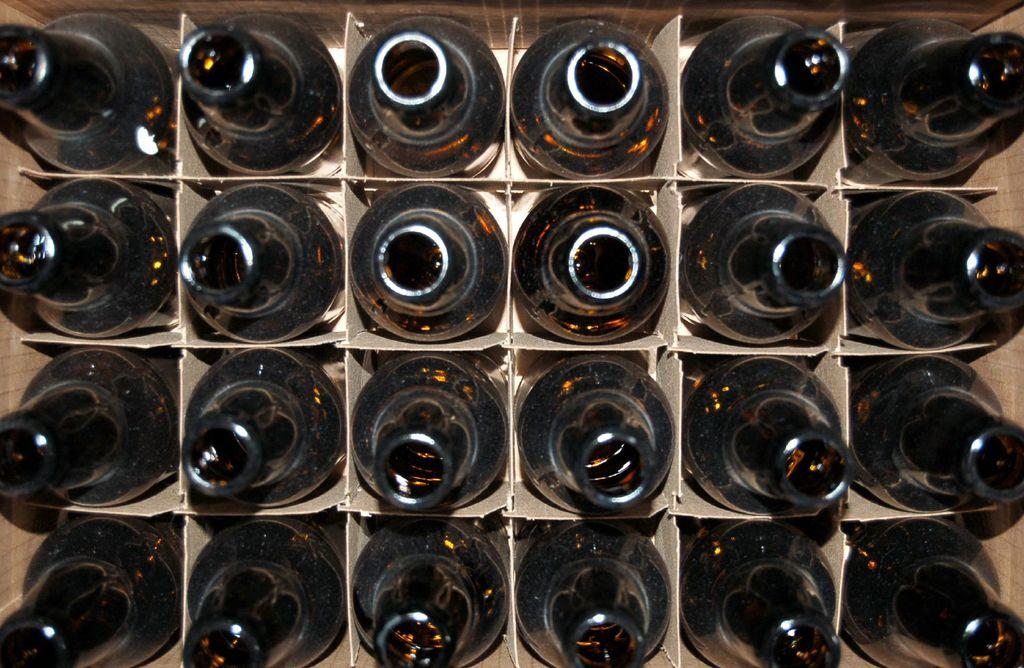What is the arrangement of the objects in the image? The objects are arranged in a row in the image. What type of container holds the objects? The objects are in a cardboard box. What color are the objects in the image? The objects are black in color. How many pages are visible in the image? There are no pages present in the image; it features a row of black bottles in a cardboard box. 